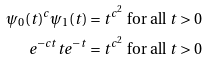<formula> <loc_0><loc_0><loc_500><loc_500>\psi _ { 0 } ( t ) ^ { c } \psi _ { 1 } ( t ) & = t ^ { c ^ { 2 } } \text { for all } t > 0 \\ e ^ { - c t } t e ^ { - t } & = t ^ { c ^ { 2 } } \text { for all } t > 0</formula> 